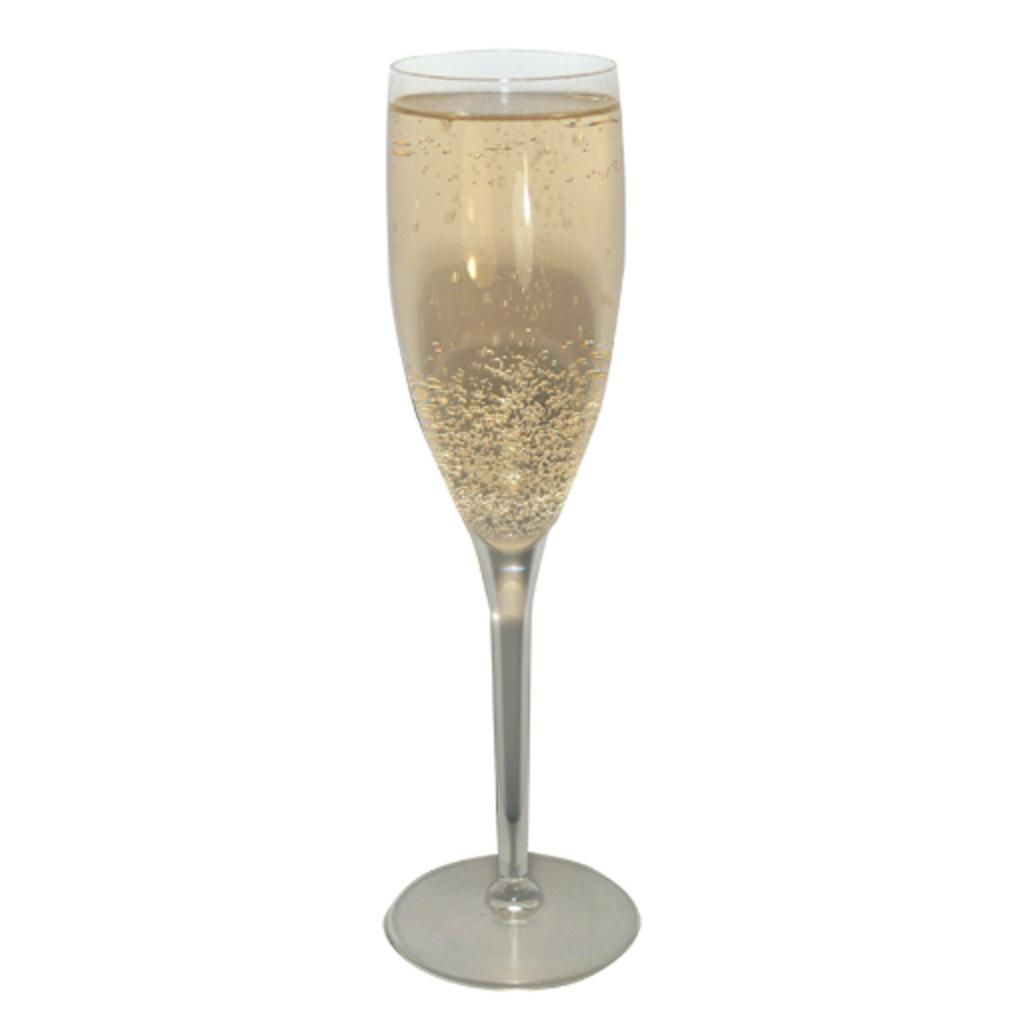What object is present in the image that can hold liquid? There is a glass in the image that can hold liquid. What is inside the glass? The glass contains liquid. What color is the background of the image? The background of the image is white. How many ducks are swimming in the liquid inside the glass? There are no ducks present in the image, and therefore no ducks swimming in the liquid inside the glass. 